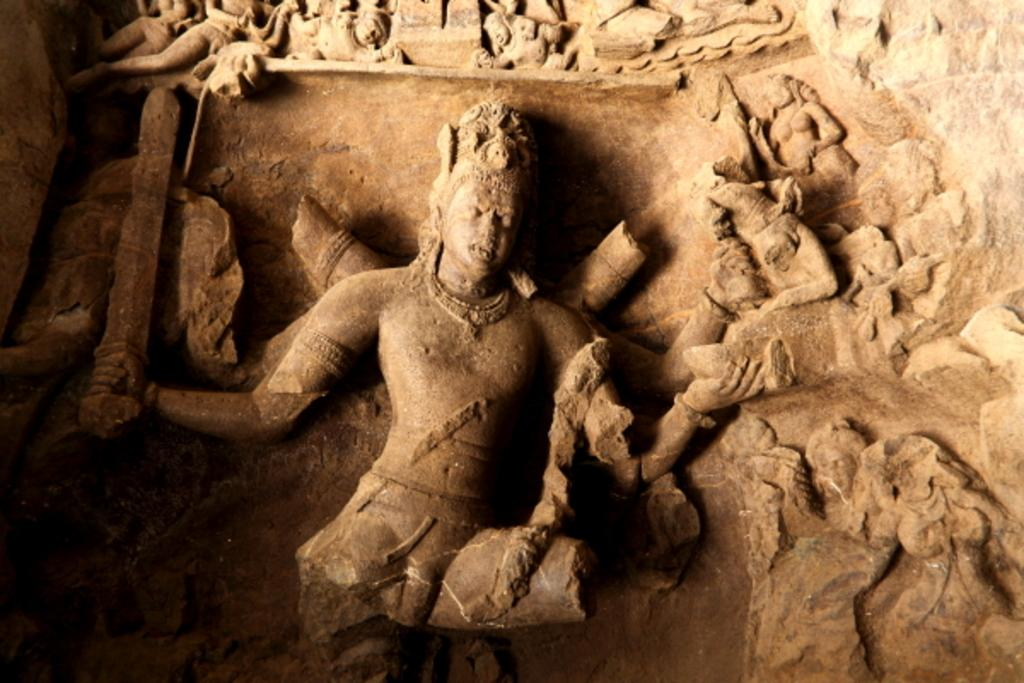What type of artifacts are depicted in the image? There are ancient stone sculptures in the image. Where are the sculptures located? The sculptures are on a wall. What type of cloud can be seen in the image? There is no cloud present in the image; it features ancient stone sculptures on a wall. What organization is responsible for maintaining the sculptures in the image? The provided facts do not mention any organization responsible for maintaining the sculptures, so we cannot answer this question. 